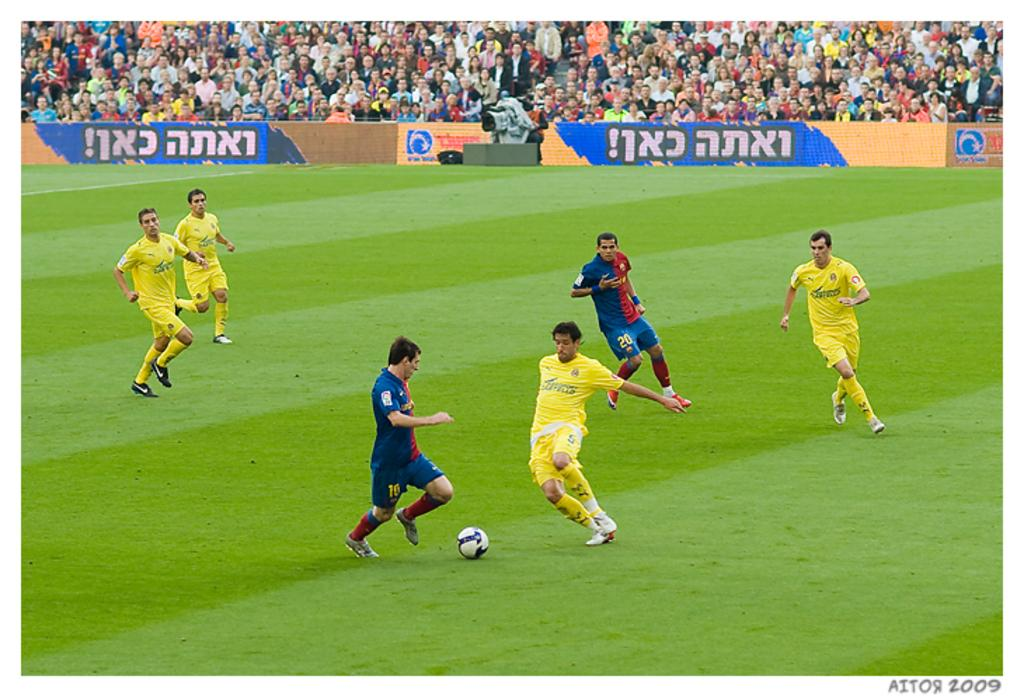Provide a one-sentence caption for the provided image. Two players from opposing teams approach the ball, the man about to kick the ball has a 15 on his shorts. 